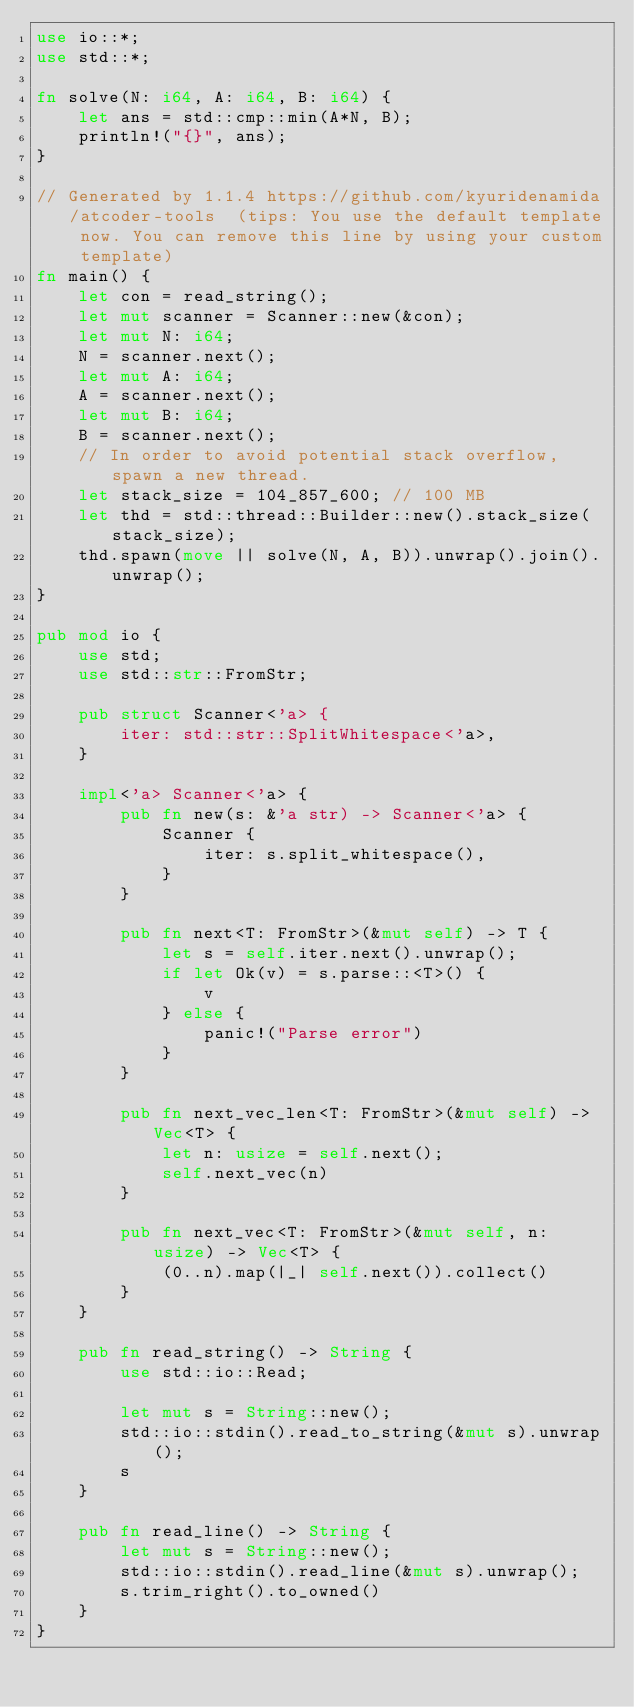Convert code to text. <code><loc_0><loc_0><loc_500><loc_500><_Rust_>use io::*;
use std::*;

fn solve(N: i64, A: i64, B: i64) {
    let ans = std::cmp::min(A*N, B);
    println!("{}", ans);
}

// Generated by 1.1.4 https://github.com/kyuridenamida/atcoder-tools  (tips: You use the default template now. You can remove this line by using your custom template)
fn main() {
    let con = read_string();
    let mut scanner = Scanner::new(&con);
    let mut N: i64;
    N = scanner.next();
    let mut A: i64;
    A = scanner.next();
    let mut B: i64;
    B = scanner.next();
    // In order to avoid potential stack overflow, spawn a new thread.
    let stack_size = 104_857_600; // 100 MB
    let thd = std::thread::Builder::new().stack_size(stack_size);
    thd.spawn(move || solve(N, A, B)).unwrap().join().unwrap();
}

pub mod io {
    use std;
    use std::str::FromStr;

    pub struct Scanner<'a> {
        iter: std::str::SplitWhitespace<'a>,
    }

    impl<'a> Scanner<'a> {
        pub fn new(s: &'a str) -> Scanner<'a> {
            Scanner {
                iter: s.split_whitespace(),
            }
        }

        pub fn next<T: FromStr>(&mut self) -> T {
            let s = self.iter.next().unwrap();
            if let Ok(v) = s.parse::<T>() {
                v
            } else {
                panic!("Parse error")
            }
        }

        pub fn next_vec_len<T: FromStr>(&mut self) -> Vec<T> {
            let n: usize = self.next();
            self.next_vec(n)
        }

        pub fn next_vec<T: FromStr>(&mut self, n: usize) -> Vec<T> {
            (0..n).map(|_| self.next()).collect()
        }
    }

    pub fn read_string() -> String {
        use std::io::Read;

        let mut s = String::new();
        std::io::stdin().read_to_string(&mut s).unwrap();
        s
    }

    pub fn read_line() -> String {
        let mut s = String::new();
        std::io::stdin().read_line(&mut s).unwrap();
        s.trim_right().to_owned()
    }
}
</code> 